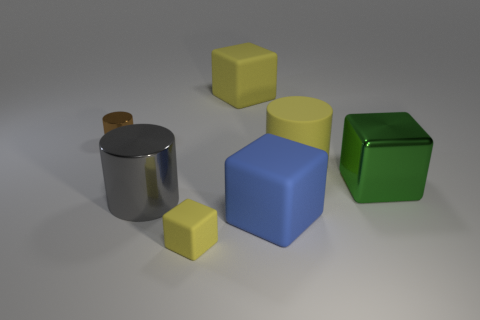How many cylinders are either big blue objects or large gray metal things?
Offer a very short reply. 1. How many large yellow matte cylinders are behind the yellow object that is to the right of the big matte block in front of the metallic block?
Offer a terse response. 0. What size is the cube that is the same color as the small rubber object?
Ensure brevity in your answer.  Large. Is there a cylinder made of the same material as the big green thing?
Ensure brevity in your answer.  Yes. Is the big green block made of the same material as the blue block?
Offer a terse response. No. There is a big rubber object in front of the green block; how many things are in front of it?
Your response must be concise. 1. What number of yellow things are tiny matte balls or large cylinders?
Provide a succinct answer. 1. What is the shape of the yellow thing that is in front of the big blue cube on the right side of the large rubber cube that is behind the large gray cylinder?
Provide a short and direct response. Cube. There is a matte cube that is the same size as the blue rubber thing; what is its color?
Provide a short and direct response. Yellow. What number of other blue things have the same shape as the large blue matte thing?
Keep it short and to the point. 0. 